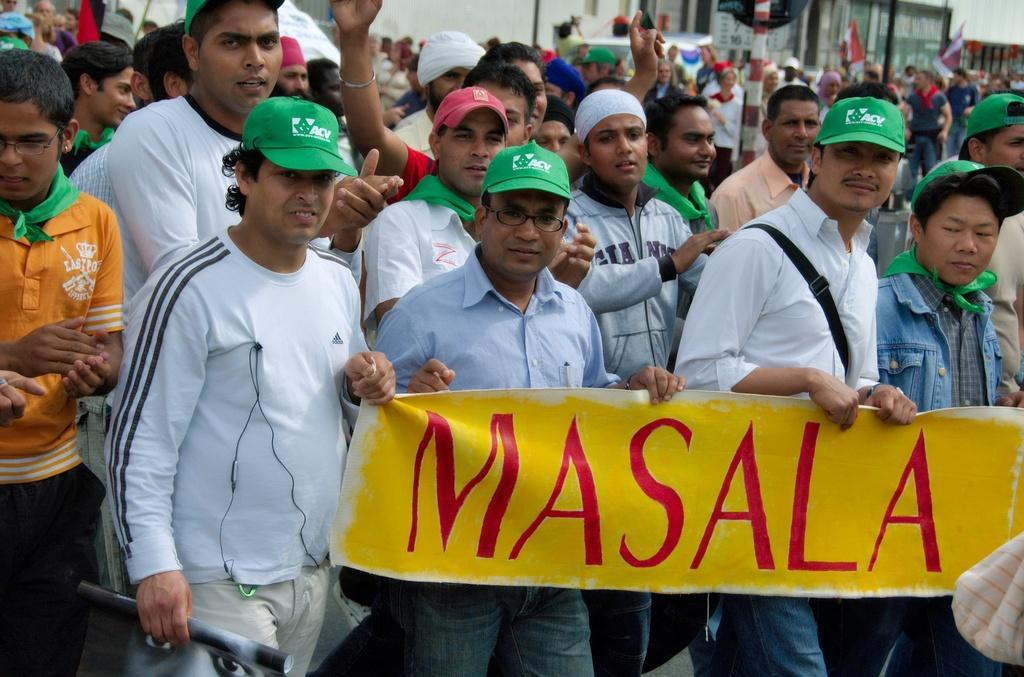How would you summarize this image in a sentence or two? In this image we can see few people, some of them are holding banners, some of them are holding flags, there is a pole with board, and it looks like a building in the background. 